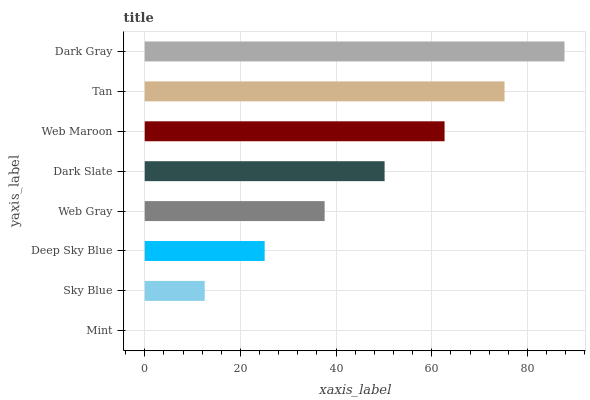Is Mint the minimum?
Answer yes or no. Yes. Is Dark Gray the maximum?
Answer yes or no. Yes. Is Sky Blue the minimum?
Answer yes or no. No. Is Sky Blue the maximum?
Answer yes or no. No. Is Sky Blue greater than Mint?
Answer yes or no. Yes. Is Mint less than Sky Blue?
Answer yes or no. Yes. Is Mint greater than Sky Blue?
Answer yes or no. No. Is Sky Blue less than Mint?
Answer yes or no. No. Is Dark Slate the high median?
Answer yes or no. Yes. Is Web Gray the low median?
Answer yes or no. Yes. Is Dark Gray the high median?
Answer yes or no. No. Is Dark Gray the low median?
Answer yes or no. No. 